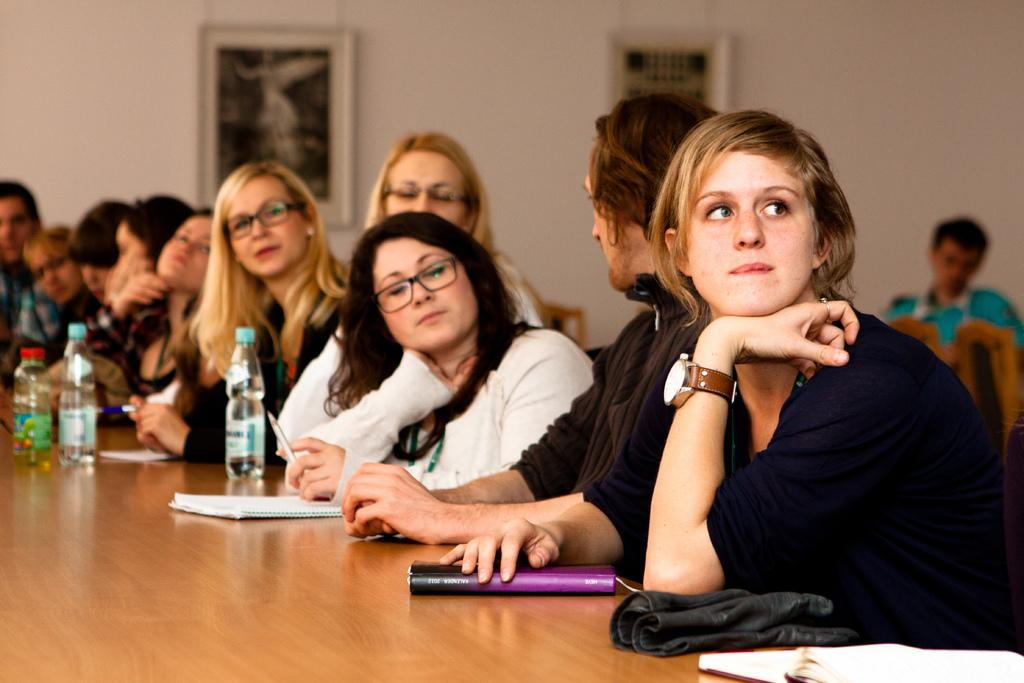What objects are on the table on the left side of the image? There are water bottles on the table on the left side of the image. What can be seen in the middle of the image? There is a group of people in the middle of the image. What is on the wall at the back side of the image? There are photo frames on the wall at the back side of the image. Is there any rain visible in the image? There is no rain present in the image. What type of spark can be seen coming from the photo frames on the wall? There is no spark present in the image; it only features photo frames on the wall. 